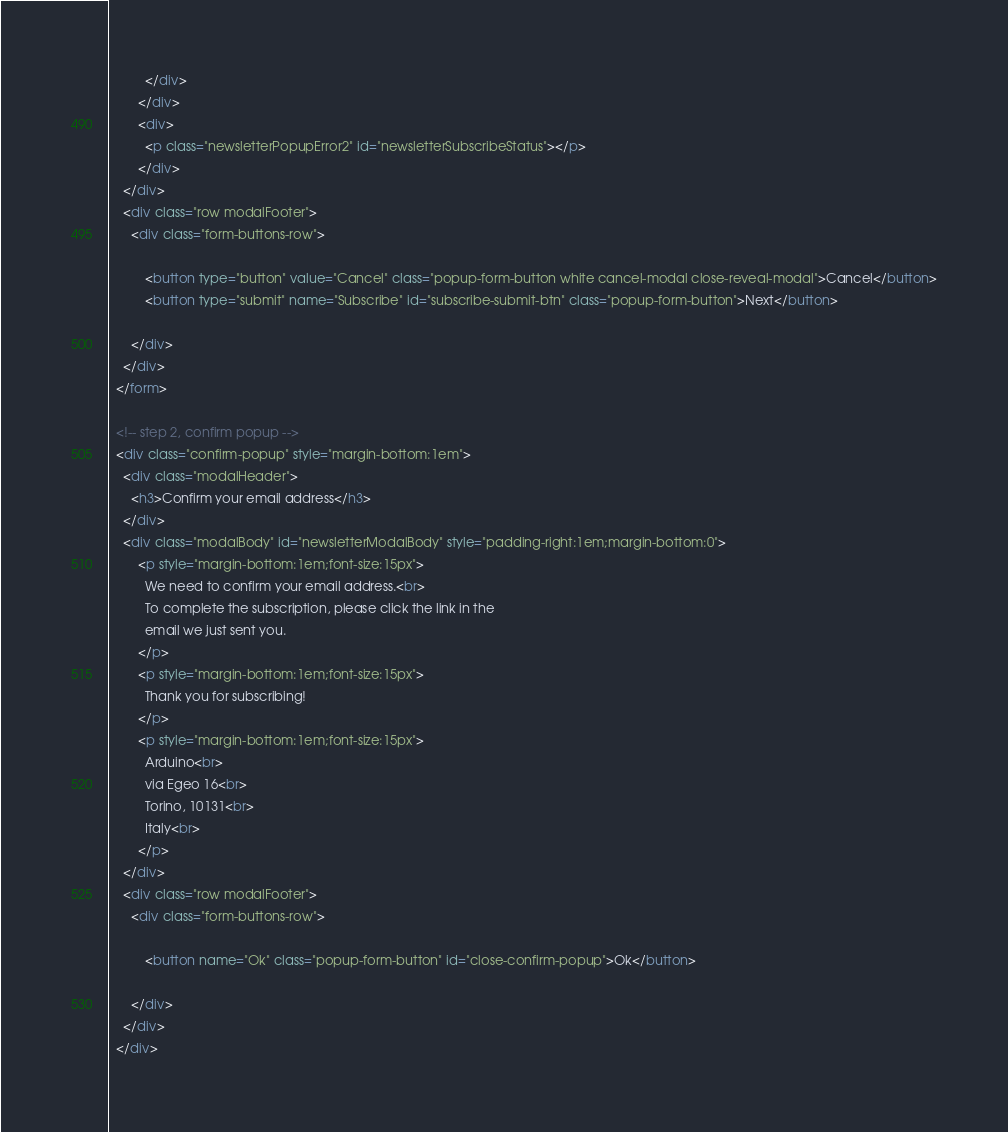Convert code to text. <code><loc_0><loc_0><loc_500><loc_500><_HTML_>          </div>
        </div>
        <div>
          <p class="newsletterPopupError2" id="newsletterSubscribeStatus"></p>
        </div>
    </div>
    <div class="row modalFooter">
      <div class="form-buttons-row">
        
          <button type="button" value="Cancel" class="popup-form-button white cancel-modal close-reveal-modal">Cancel</button>
          <button type="submit" name="Subscribe" id="subscribe-submit-btn" class="popup-form-button">Next</button>
        
      </div>
    </div>
  </form>

  <!-- step 2, confirm popup -->
  <div class="confirm-popup" style="margin-bottom:1em">
    <div class="modalHeader">
      <h3>Confirm your email address</h3>
    </div>
    <div class="modalBody" id="newsletterModalBody" style="padding-right:1em;margin-bottom:0">
        <p style="margin-bottom:1em;font-size:15px">
          We need to confirm your email address.<br>
          To complete the subscription, please click the link in the
          email we just sent you.
        </p>
        <p style="margin-bottom:1em;font-size:15px">
          Thank you for subscribing!
        </p>
        <p style="margin-bottom:1em;font-size:15px">
          Arduino<br>
          via Egeo 16<br>
          Torino, 10131<br>
          Italy<br>
        </p>
    </div>
    <div class="row modalFooter">
      <div class="form-buttons-row">
        
          <button name="Ok" class="popup-form-button" id="close-confirm-popup">Ok</button>

      </div>
    </div>
  </div>
</code> 